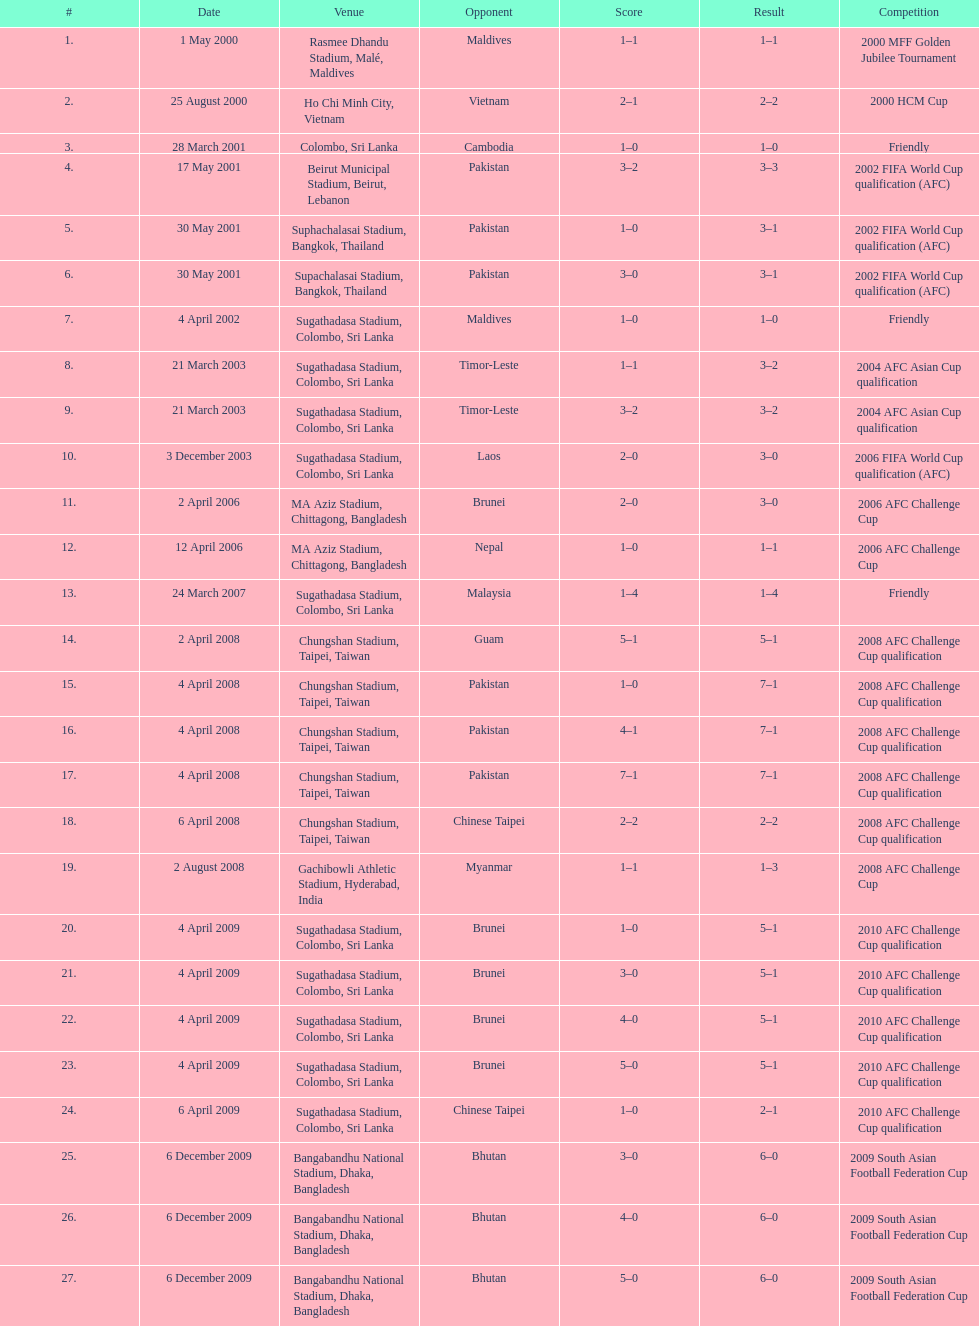How many instances was laos the opposition? 1. 